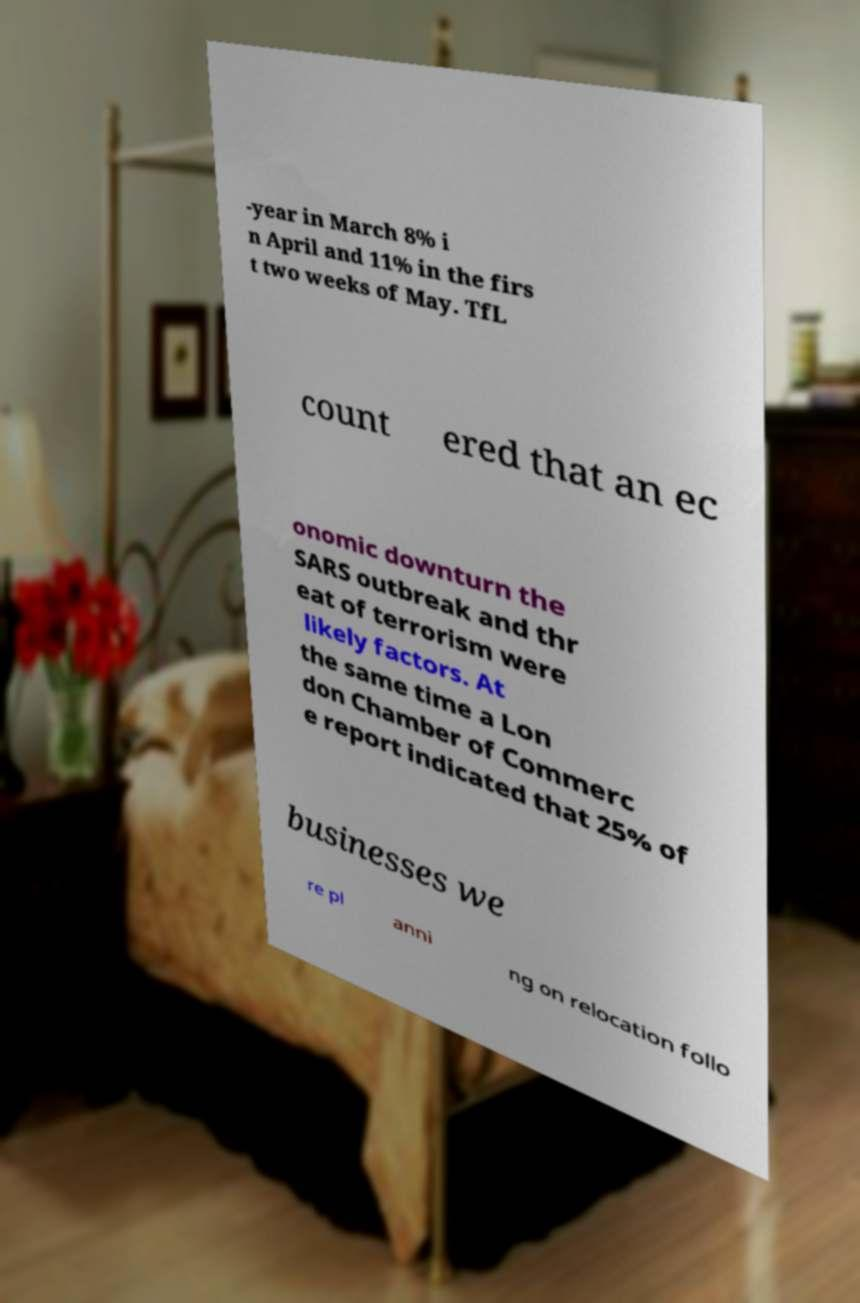There's text embedded in this image that I need extracted. Can you transcribe it verbatim? -year in March 8% i n April and 11% in the firs t two weeks of May. TfL count ered that an ec onomic downturn the SARS outbreak and thr eat of terrorism were likely factors. At the same time a Lon don Chamber of Commerc e report indicated that 25% of businesses we re pl anni ng on relocation follo 